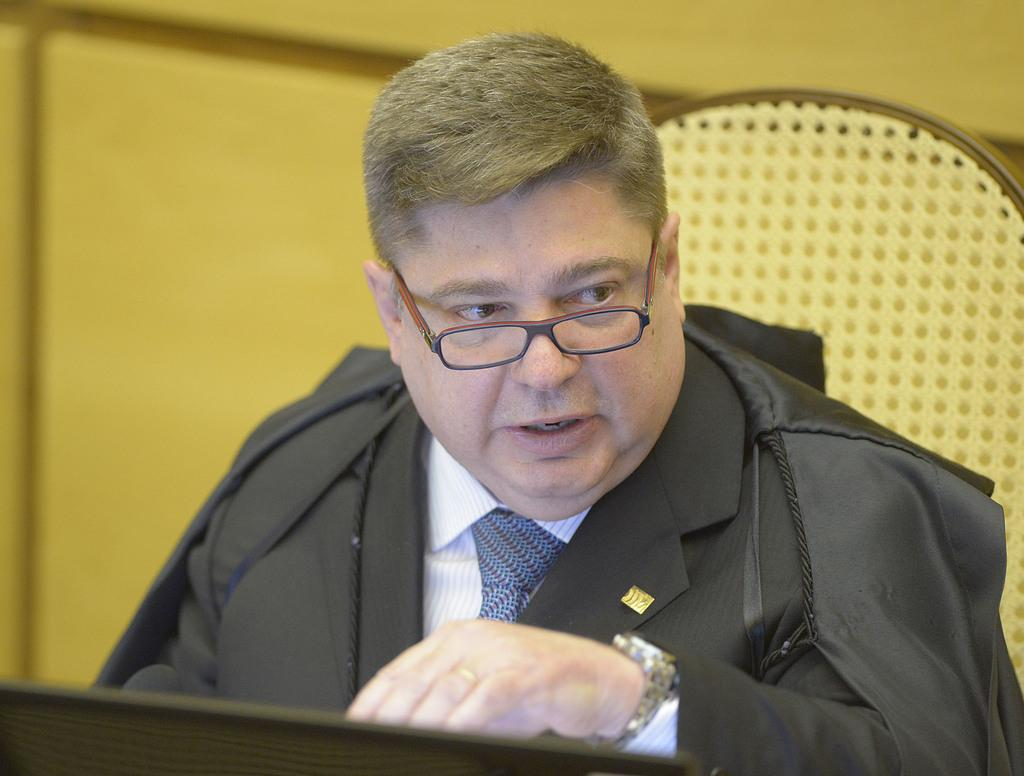Who is present in the image? There is a man in the image. What is the man doing in the image? The man is sitting on a chair. What is the man wearing in the image? The man is wearing a black jacket and a wristwatch. Can you describe the background of the image? The background of the image is blurred. Can you tell me how many snails are crawling on the man's wristwatch in the image? There are no snails present in the image, so it is not possible to determine how many might be crawling on the man's wristwatch. 